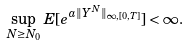<formula> <loc_0><loc_0><loc_500><loc_500>\sup _ { N \geq N _ { 0 } } E [ e ^ { a \| Y ^ { N } \| _ { \infty , [ 0 , T ] } } ] < \infty .</formula> 